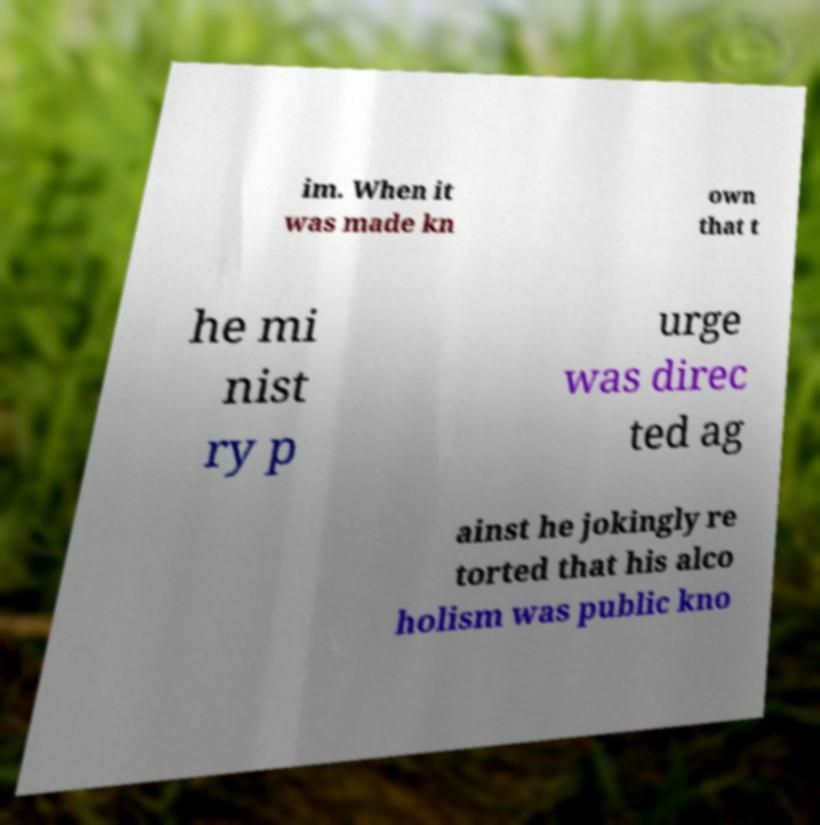Could you assist in decoding the text presented in this image and type it out clearly? im. When it was made kn own that t he mi nist ry p urge was direc ted ag ainst he jokingly re torted that his alco holism was public kno 